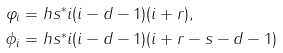Convert formula to latex. <formula><loc_0><loc_0><loc_500><loc_500>\varphi _ { i } & = h s ^ { * } i ( i - d - 1 ) ( i + r ) , \\ \phi _ { i } & = h s ^ { * } i ( i - d - 1 ) ( i + r - s - d - 1 )</formula> 